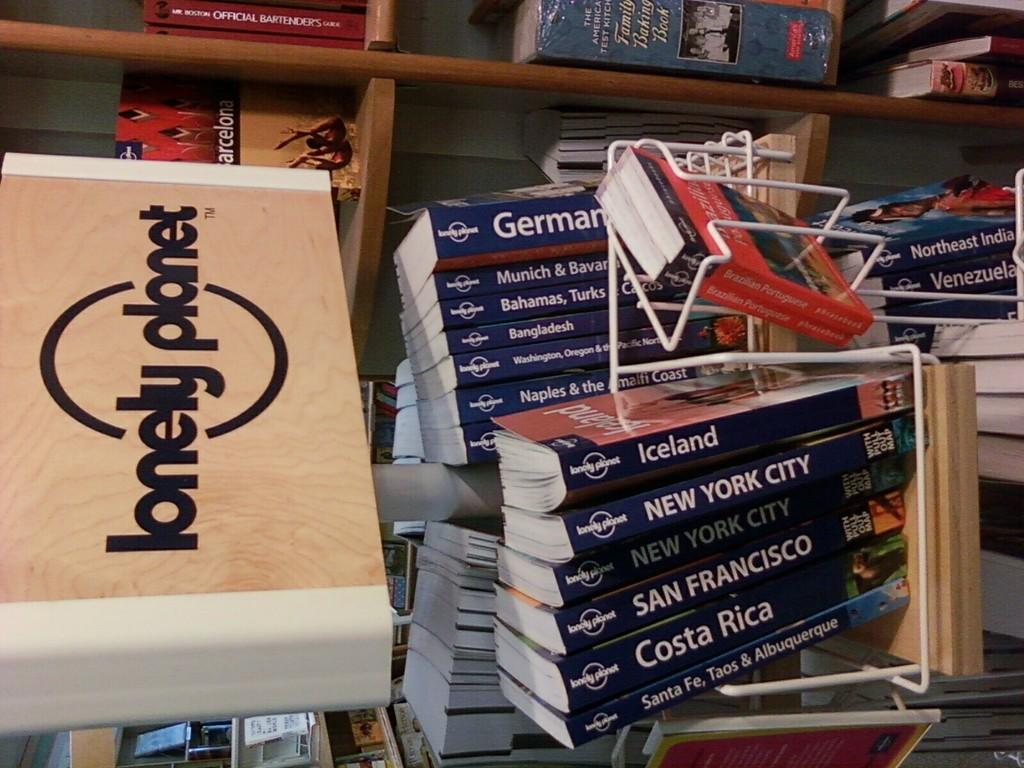<image>
Offer a succinct explanation of the picture presented. Books inside a store with one that says Costa Rica on the bottom. 